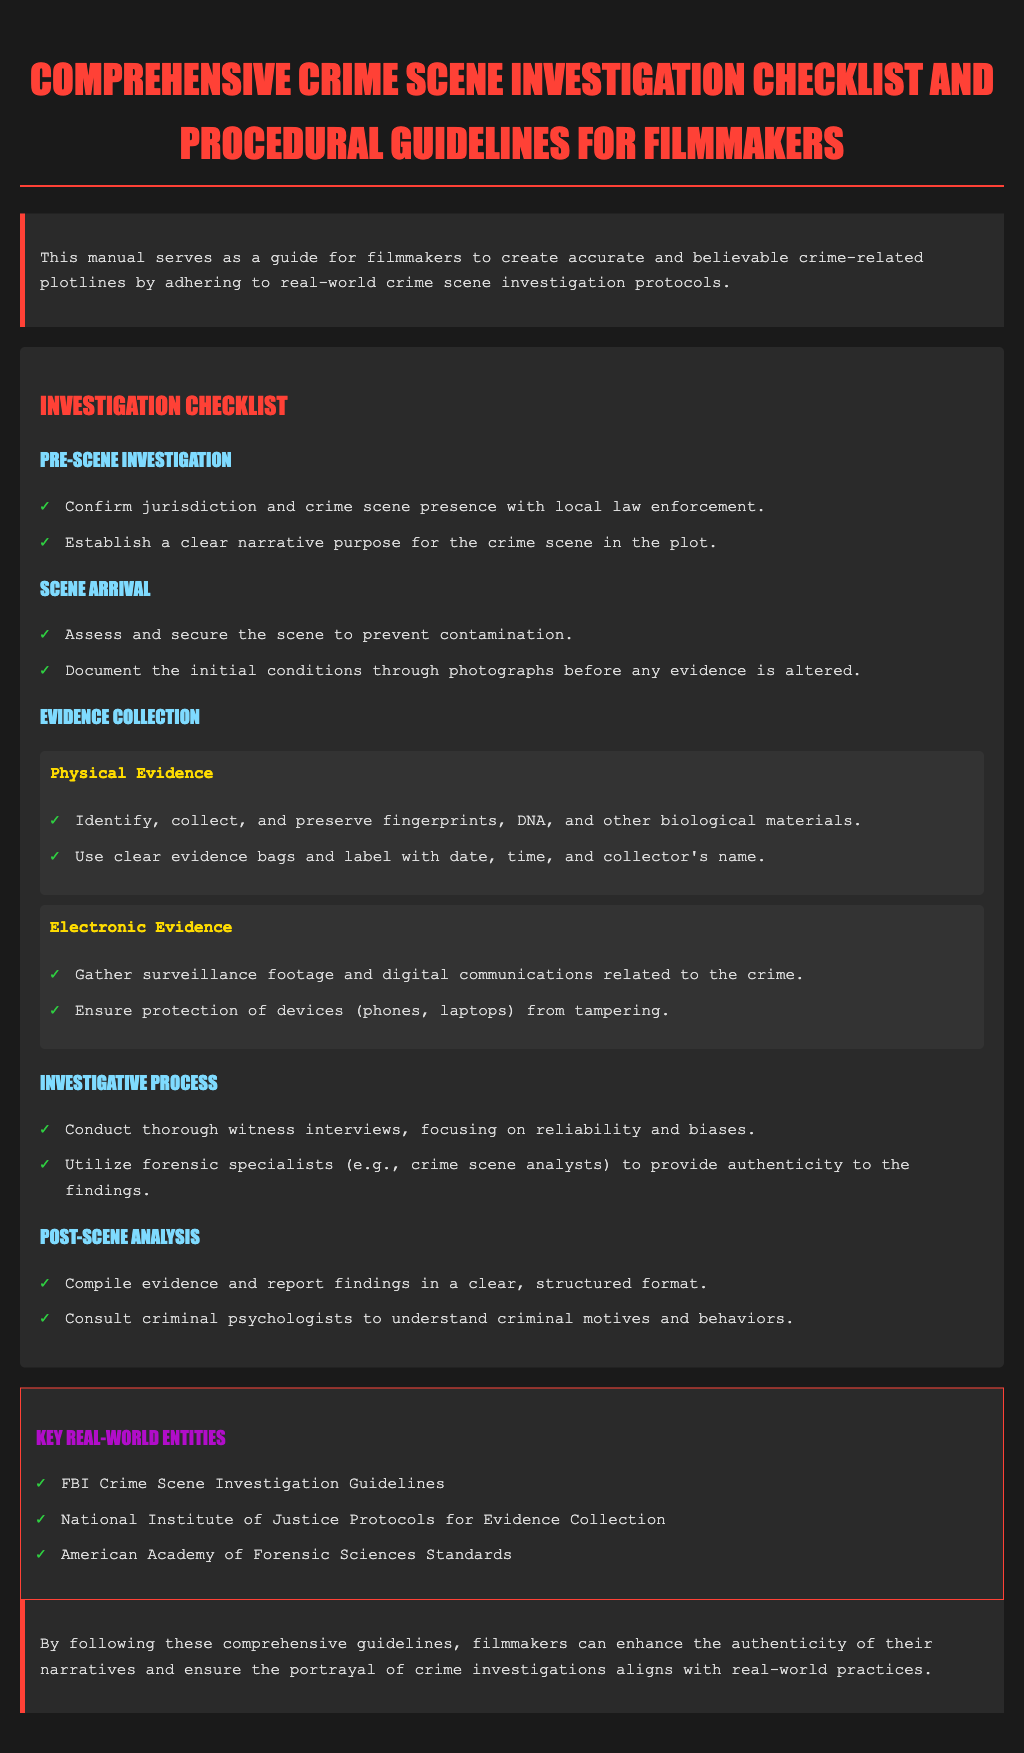What is the title of the document? The title of the document is presented prominently at the top.
Answer: Comprehensive Crime Scene Investigation Checklist and Procedural Guidelines for Filmmakers What is the purpose of the manual? The purpose is stated in the introduction section, explaining the intent behind the guidelines.
Answer: To create accurate and believable crime-related plotlines What should be done before arriving at the scene? The checklist provides actions to be taken prior to scene arrival.
Answer: Confirm jurisdiction and crime scene presence What type of evidence is mentioned for collection? The evidence collection section lists categories of evidence that should be gathered.
Answer: Physical Evidence Who should be consulted for understanding criminal motives? The post-scene analysis section advises consulting specific professionals.
Answer: Criminal psychologists How are fingerprints supposed to be handled? The evidence collection section details how to collect and preserve fingerprints.
Answer: Identify, collect, and preserve fingerprints What is the main color of the checklist background? The document's styling specifies the background color for the checklist area.
Answer: Dark gray Name one guideline mentioned for electronic evidence. The electronic evidence section outlines specific actions for digital materials.
Answer: Gather surveillance footage Which body provides guidelines for crime scene investigations? The key entities section lists authoritative organizations related to crime scene protocols.
Answer: FBI Crime Scene Investigation Guidelines 